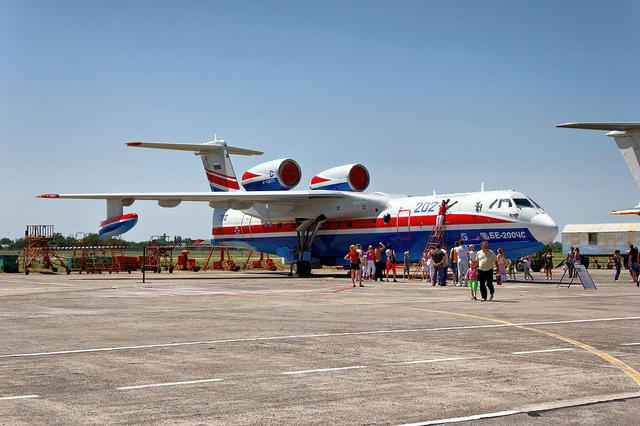How many people can this plane hold?
Keep it brief. Hundreds. Is the plane boarding?
Answer briefly. No. How many different colors does the plane have?
Quick response, please. 3. 